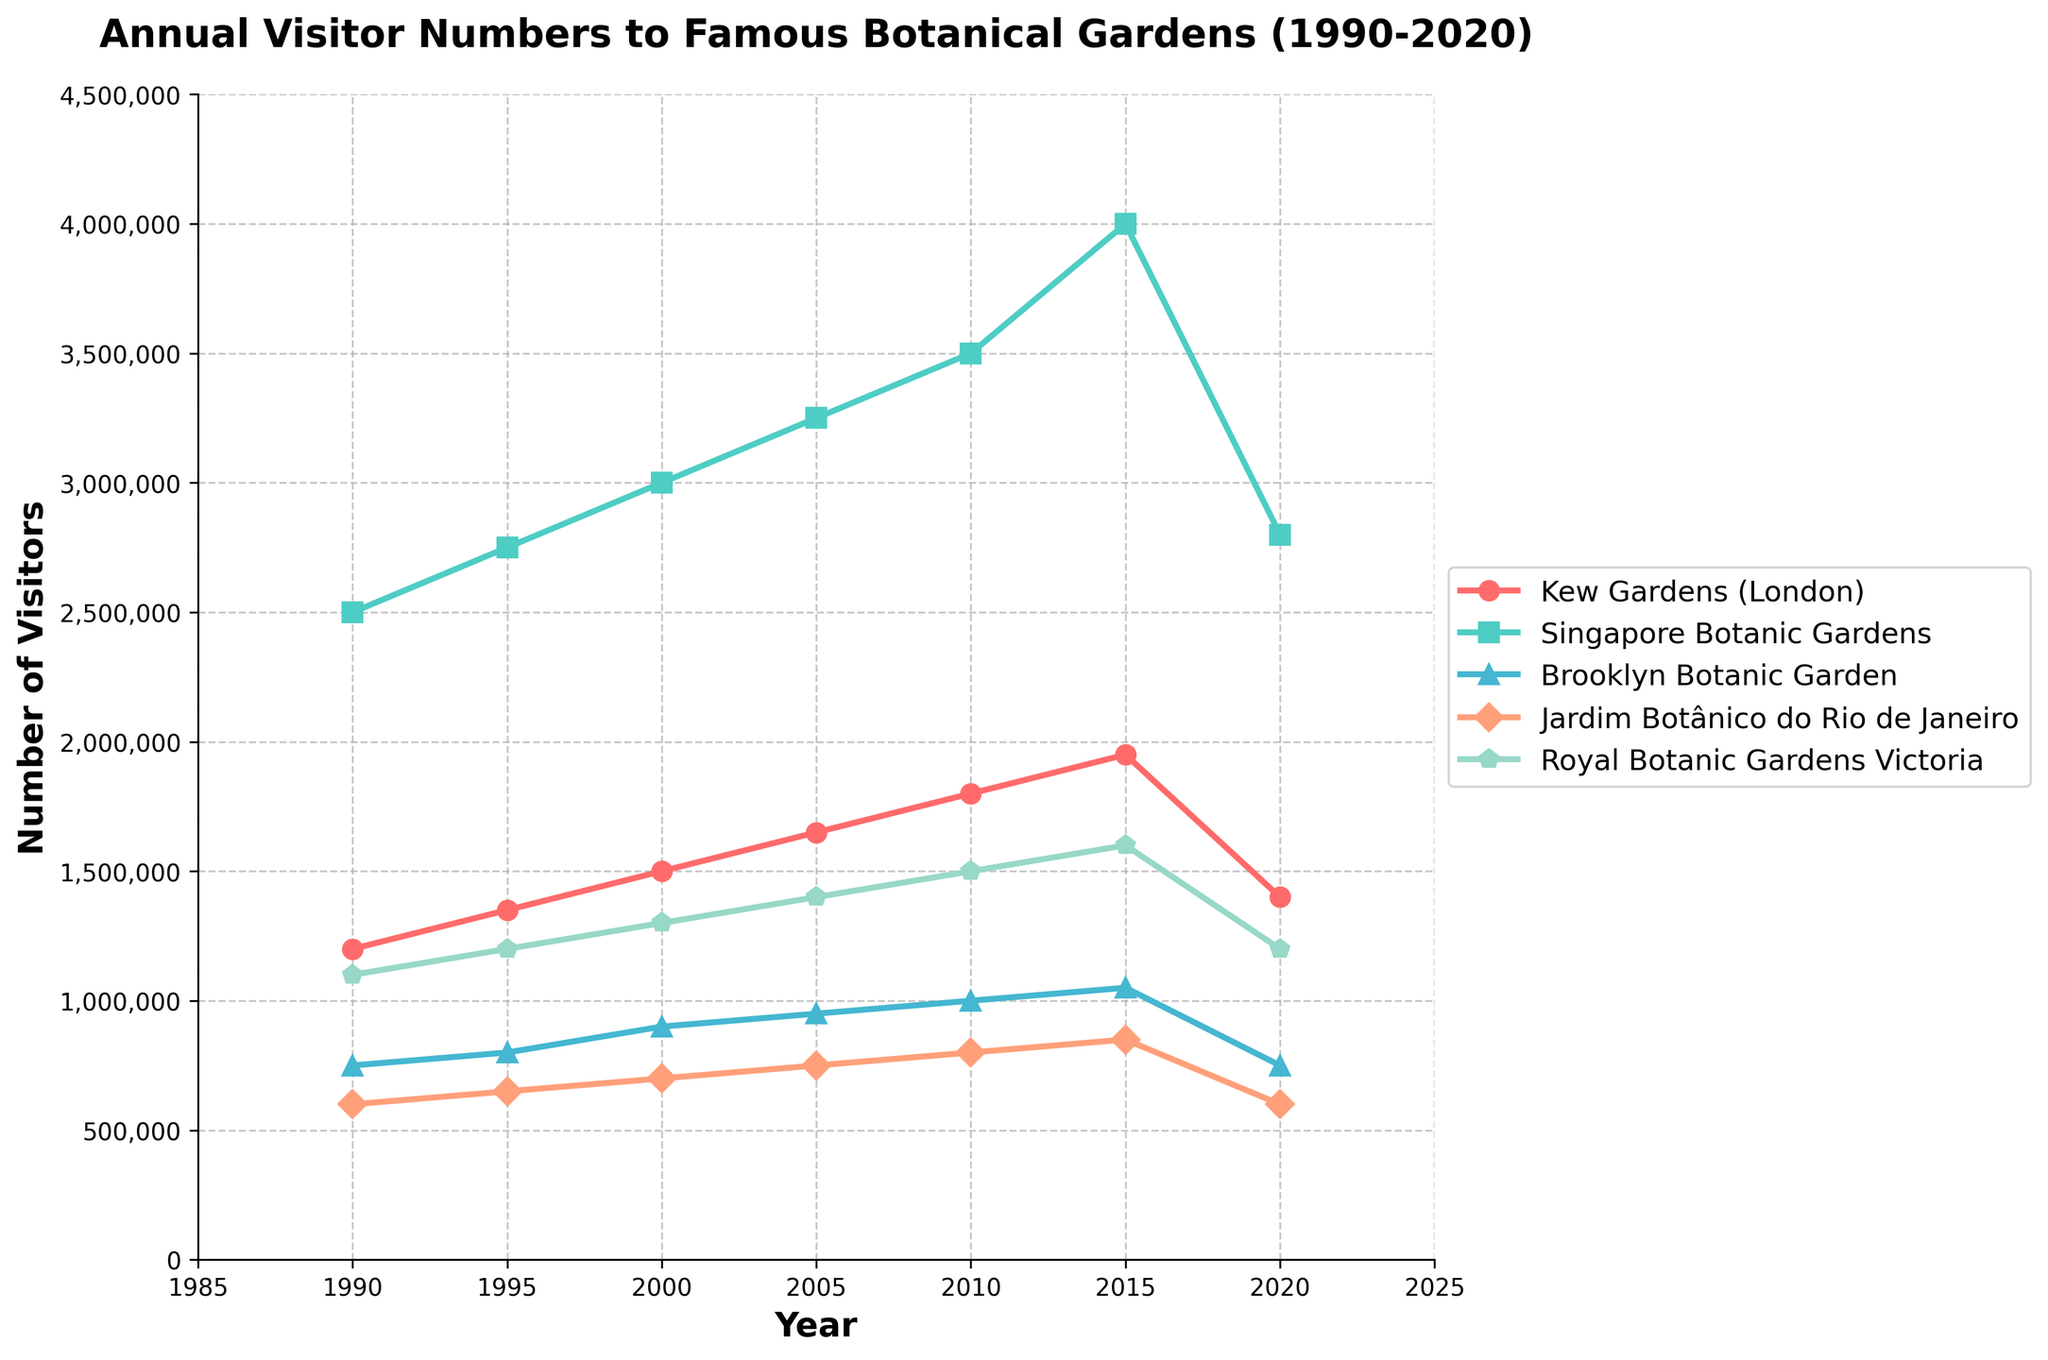Which botanical garden had the highest number of visitors in 2015? Look at the data points for 2015 across all gardens; observe that Singapore Botanic Gardens had the highest visitors.
Answer: Singapore Botanic Gardens How did visitor numbers at Kew Gardens (London) change from 2010 to 2020? Compare the visitor numbers for Kew Gardens (London) in 2010 and 2020. Subtract the latter from the former to find the change.
Answer: Decreased Which two botanical gardens had the closest number of visitors in 2020? Compare the visitor numbers of all gardens in 2020. Note that Brooklyn Botanic Garden and Jardim Botânico do Rio de Janeiro both had 750,000 visitors.
Answer: Brooklyn Botanic Garden, Jardim Botânico do Rio de Janeiro What is the average number of visitors to the Royal Botanic Gardens Victoria from 1990 to 2020? Sum the visitor numbers for Royal Botanic Gardens Victoria from 1990 to 2020, then divide by the number of data points (7).
Answer: 1371429 Between 1990 and 2000, which garden had the highest increase in visitor numbers? Calculate the difference in visitors for each garden between 1990 and 2000. The Singapore Botanic Gardens had the highest increase of 500,000 visitors.
Answer: Singapore Botanic Gardens In which year did Brooklyn Botanic Garden have a peak in visitors, and what was the number? Identify the highest data point for Brooklyn Botanic Garden within the plot. Note that it peaked in 2015 with 1,050,000 visitors.
Answer: 2015, 1,050,000 Which botanical garden experienced the steepest decline in visitor numbers from 2015 to 2020? Look at the differences in visitor numbers for each garden between 2015 and 2020. Singapore Botanic Gardens had the steepest decline from 4,000,000 to 2,800,000.
Answer: Singapore Botanic Gardens Compare the visitor trends of Kew Gardens and Royal Botanic Gardens Victoria from 1995 to 2005. Analyze the plot lines for Kew Gardens and Royal Botanic Gardens Victoria from 1995 to 2005; both show an upward trend with a steady increase.
Answer: Both increasing Is there any year where two or more gardens had the same number of visitors? If yes, name them and the year. Check each year for identical visitor numbers across any two or more gardens. In 2020, Brooklyn Botanic Garden and Jardim Botânico do Rio de Janeiro both had 750,000 visitors.
Answer: 2020, Brooklyn Botanic Garden, Jardim Botânico do Rio de Janeiro 